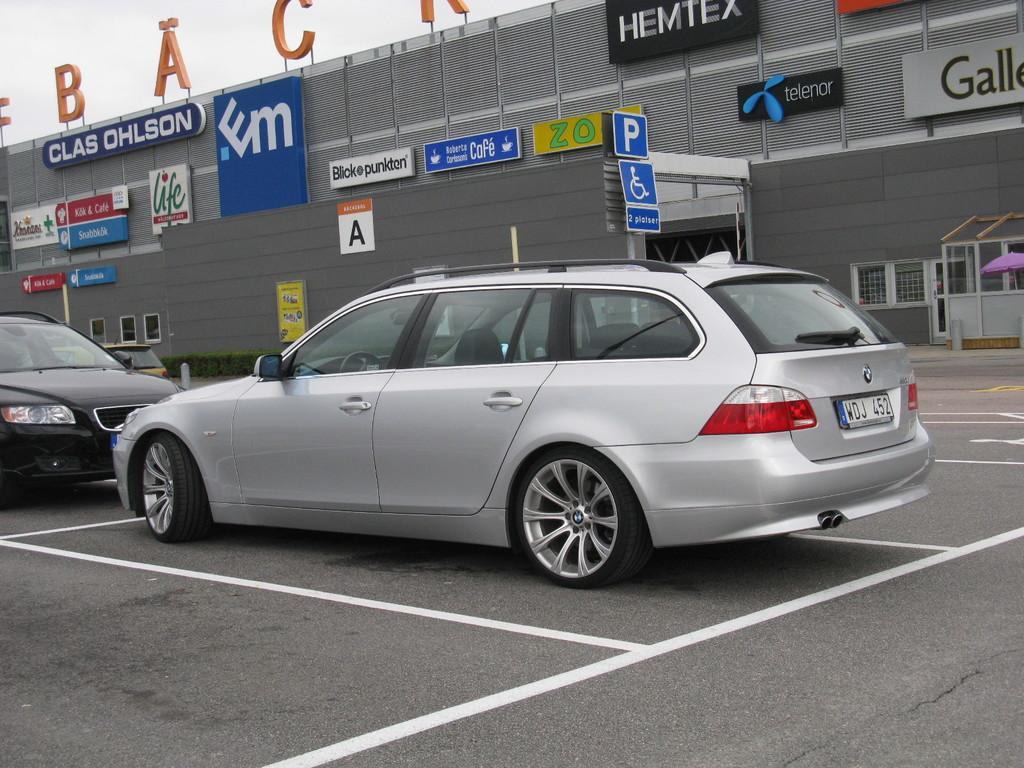<image>
Offer a succinct explanation of the picture presented. Silver car in front of a building that says "HEMTEX" on it. 